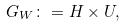<formula> <loc_0><loc_0><loc_500><loc_500>G _ { W } \colon = H \times U ,</formula> 